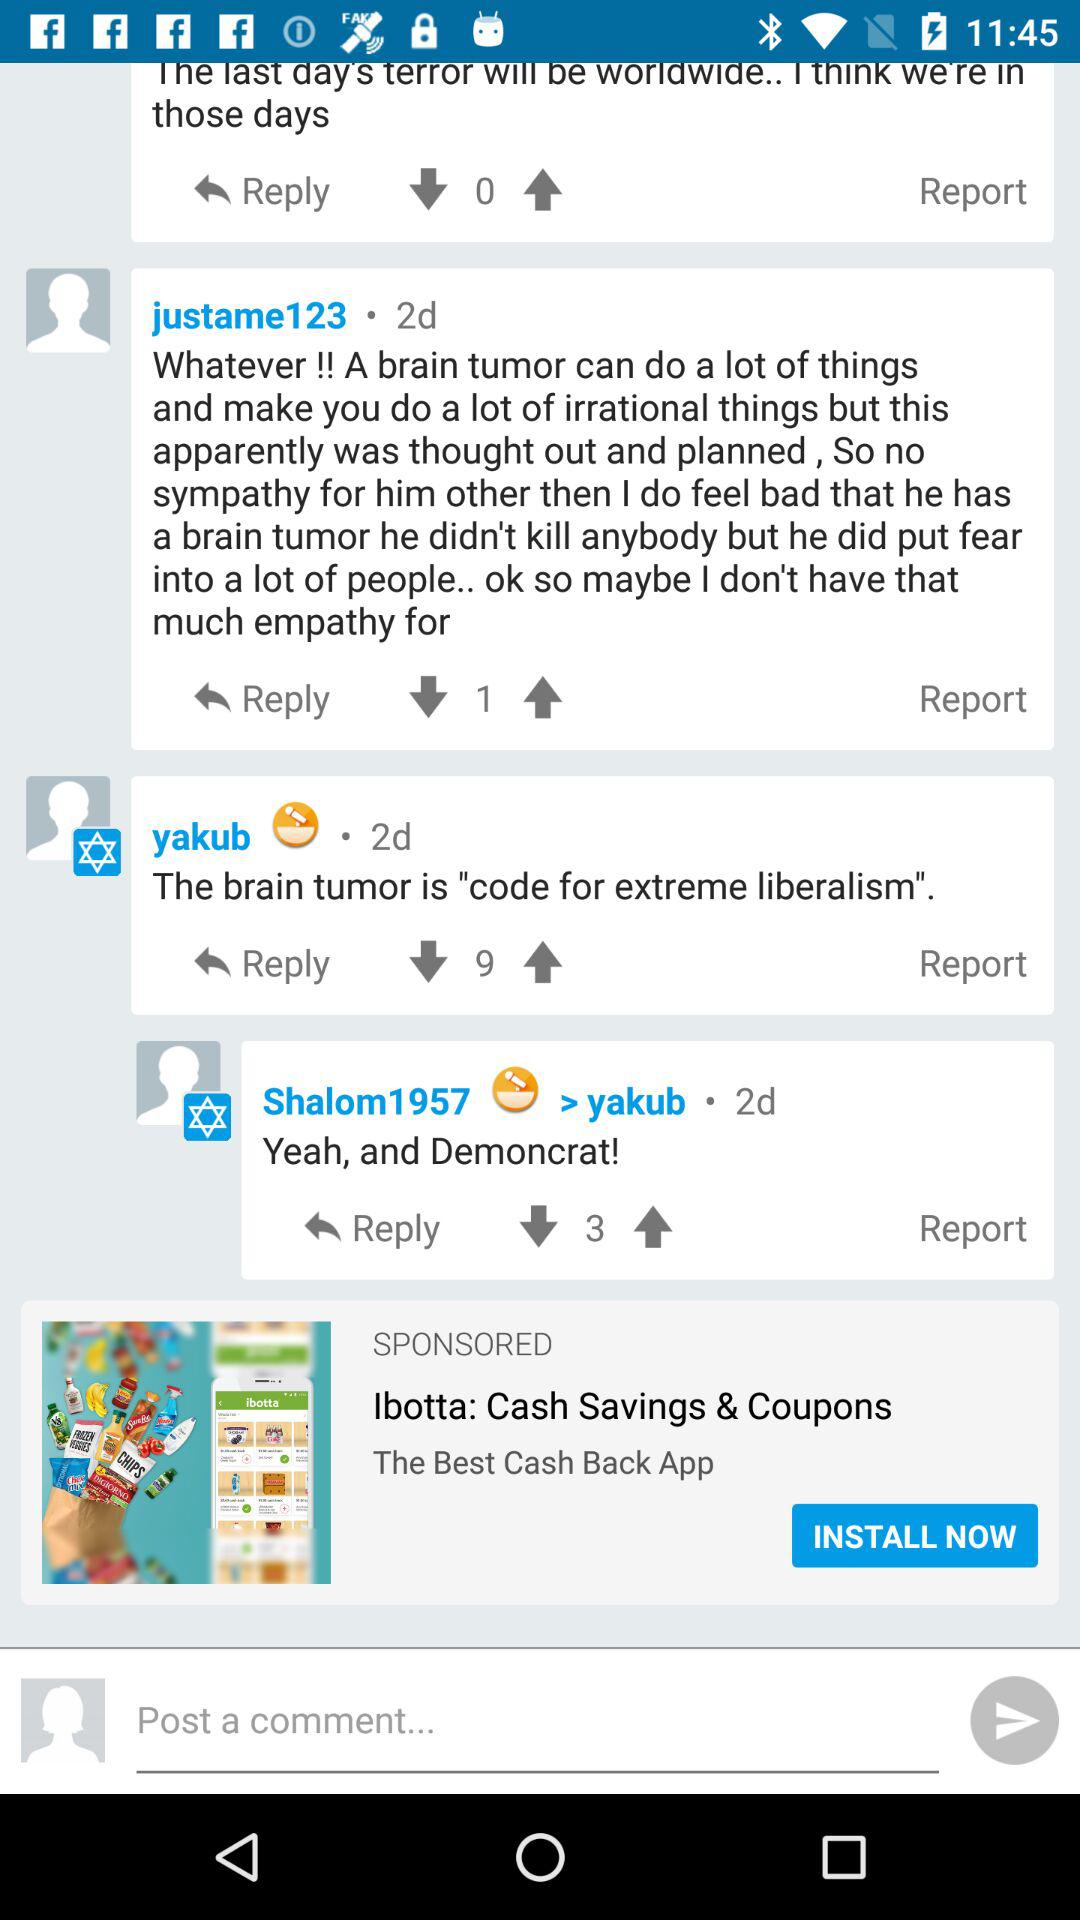Who will receive the public profile? The public profile will be received by "Riversip". 